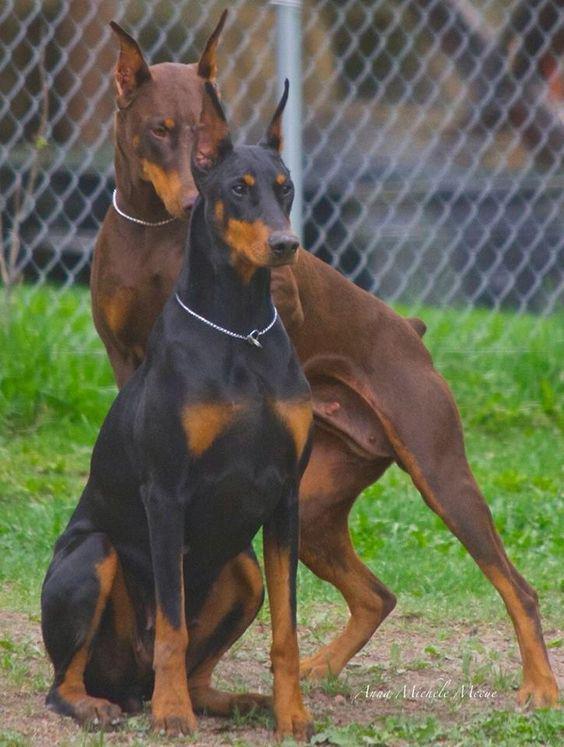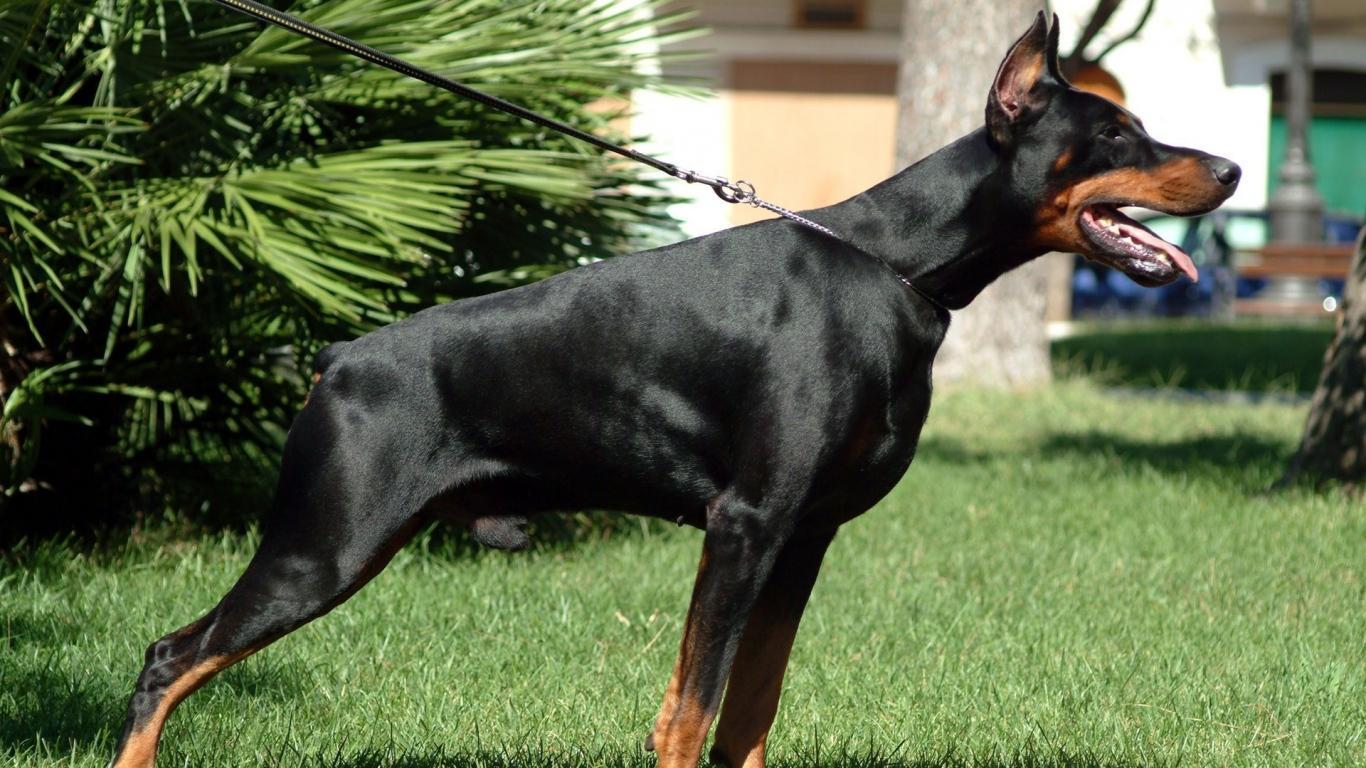The first image is the image on the left, the second image is the image on the right. Assess this claim about the two images: "The left image contains exactly one dog.". Correct or not? Answer yes or no. No. 